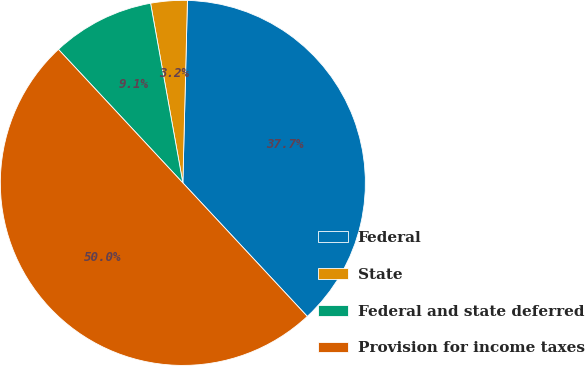<chart> <loc_0><loc_0><loc_500><loc_500><pie_chart><fcel>Federal<fcel>State<fcel>Federal and state deferred<fcel>Provision for income taxes<nl><fcel>37.66%<fcel>3.23%<fcel>9.11%<fcel>50.0%<nl></chart> 